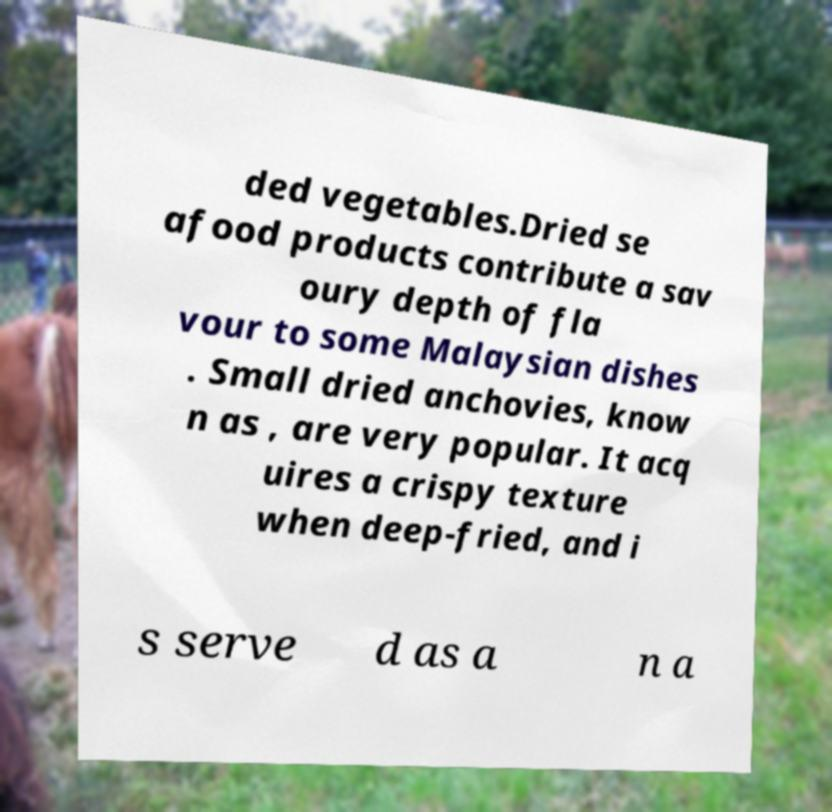Could you assist in decoding the text presented in this image and type it out clearly? ded vegetables.Dried se afood products contribute a sav oury depth of fla vour to some Malaysian dishes . Small dried anchovies, know n as , are very popular. It acq uires a crispy texture when deep-fried, and i s serve d as a n a 